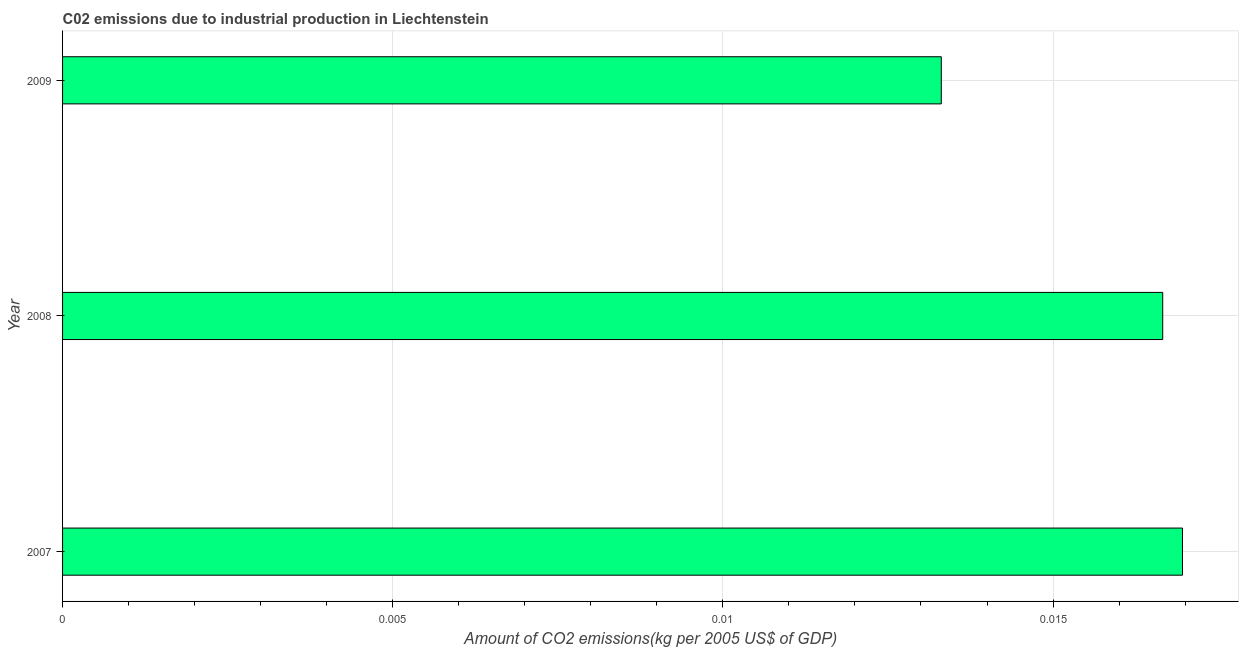What is the title of the graph?
Provide a succinct answer. C02 emissions due to industrial production in Liechtenstein. What is the label or title of the X-axis?
Your response must be concise. Amount of CO2 emissions(kg per 2005 US$ of GDP). What is the label or title of the Y-axis?
Make the answer very short. Year. What is the amount of co2 emissions in 2009?
Ensure brevity in your answer.  0.01. Across all years, what is the maximum amount of co2 emissions?
Your response must be concise. 0.02. Across all years, what is the minimum amount of co2 emissions?
Your answer should be very brief. 0.01. In which year was the amount of co2 emissions minimum?
Keep it short and to the point. 2009. What is the sum of the amount of co2 emissions?
Ensure brevity in your answer.  0.05. What is the difference between the amount of co2 emissions in 2008 and 2009?
Offer a terse response. 0. What is the average amount of co2 emissions per year?
Give a very brief answer. 0.02. What is the median amount of co2 emissions?
Give a very brief answer. 0.02. Do a majority of the years between 2008 and 2007 (inclusive) have amount of co2 emissions greater than 0.016 kg per 2005 US$ of GDP?
Offer a very short reply. No. What is the ratio of the amount of co2 emissions in 2007 to that in 2009?
Keep it short and to the point. 1.27. Is the amount of co2 emissions in 2007 less than that in 2008?
Keep it short and to the point. No. Is the difference between the amount of co2 emissions in 2007 and 2009 greater than the difference between any two years?
Provide a short and direct response. Yes. What is the difference between the highest and the second highest amount of co2 emissions?
Keep it short and to the point. 0. What is the difference between the highest and the lowest amount of co2 emissions?
Your answer should be very brief. 0. In how many years, is the amount of co2 emissions greater than the average amount of co2 emissions taken over all years?
Offer a terse response. 2. How many bars are there?
Make the answer very short. 3. What is the difference between two consecutive major ticks on the X-axis?
Your response must be concise. 0.01. What is the Amount of CO2 emissions(kg per 2005 US$ of GDP) of 2007?
Offer a very short reply. 0.02. What is the Amount of CO2 emissions(kg per 2005 US$ of GDP) of 2008?
Give a very brief answer. 0.02. What is the Amount of CO2 emissions(kg per 2005 US$ of GDP) of 2009?
Ensure brevity in your answer.  0.01. What is the difference between the Amount of CO2 emissions(kg per 2005 US$ of GDP) in 2007 and 2009?
Provide a succinct answer. 0. What is the difference between the Amount of CO2 emissions(kg per 2005 US$ of GDP) in 2008 and 2009?
Make the answer very short. 0. What is the ratio of the Amount of CO2 emissions(kg per 2005 US$ of GDP) in 2007 to that in 2009?
Your answer should be compact. 1.27. What is the ratio of the Amount of CO2 emissions(kg per 2005 US$ of GDP) in 2008 to that in 2009?
Make the answer very short. 1.25. 